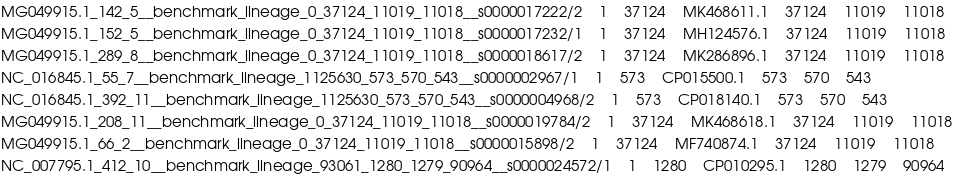Convert code to text. <code><loc_0><loc_0><loc_500><loc_500><_SQL_>MG049915.1_142_5__benchmark_lineage_0_37124_11019_11018__s0000017222/2	1	37124	MK468611.1	37124	11019	11018
MG049915.1_152_5__benchmark_lineage_0_37124_11019_11018__s0000017232/1	1	37124	MH124576.1	37124	11019	11018
MG049915.1_289_8__benchmark_lineage_0_37124_11019_11018__s0000018617/2	1	37124	MK286896.1	37124	11019	11018
NC_016845.1_55_7__benchmark_lineage_1125630_573_570_543__s0000002967/1	1	573	CP015500.1	573	570	543
NC_016845.1_392_11__benchmark_lineage_1125630_573_570_543__s0000004968/2	1	573	CP018140.1	573	570	543
MG049915.1_208_11__benchmark_lineage_0_37124_11019_11018__s0000019784/2	1	37124	MK468618.1	37124	11019	11018
MG049915.1_66_2__benchmark_lineage_0_37124_11019_11018__s0000015898/2	1	37124	MF740874.1	37124	11019	11018
NC_007795.1_412_10__benchmark_lineage_93061_1280_1279_90964__s0000024572/1	1	1280	CP010295.1	1280	1279	90964</code> 